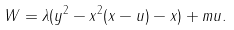Convert formula to latex. <formula><loc_0><loc_0><loc_500><loc_500>W = \lambda ( y ^ { 2 } - x ^ { 2 } ( x - u ) - x ) + m u .</formula> 